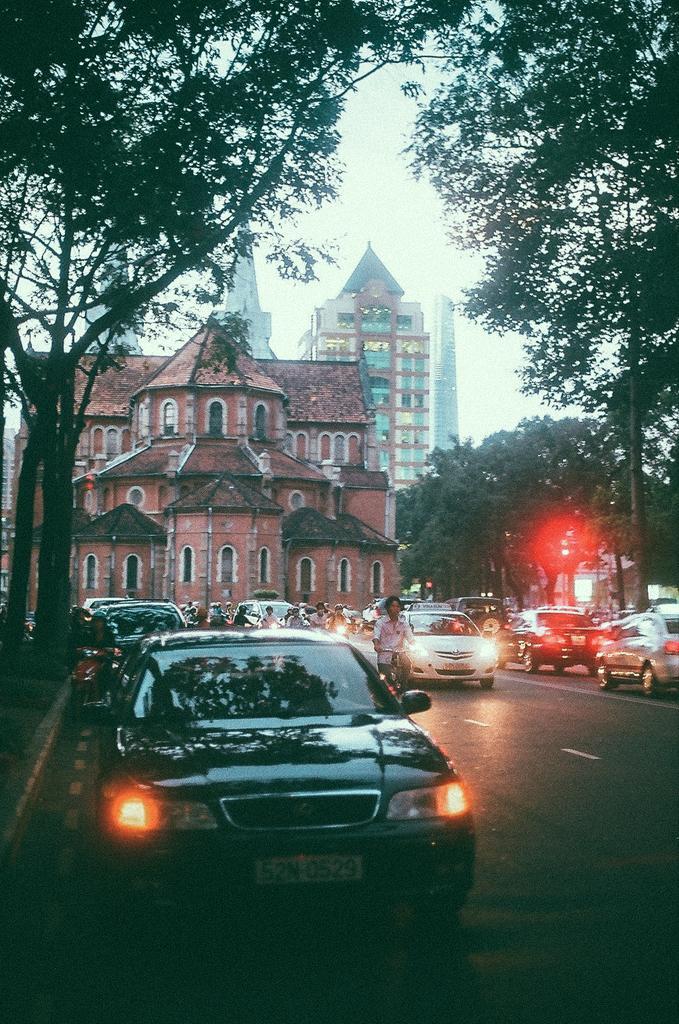Please provide a concise description of this image. Bottom of the image there are some vehicles on the road and few people are riding motorcycles and bicycles. In the middle of the image there are some trees and buildings. Behind the buildings there are some clouds and sky. 